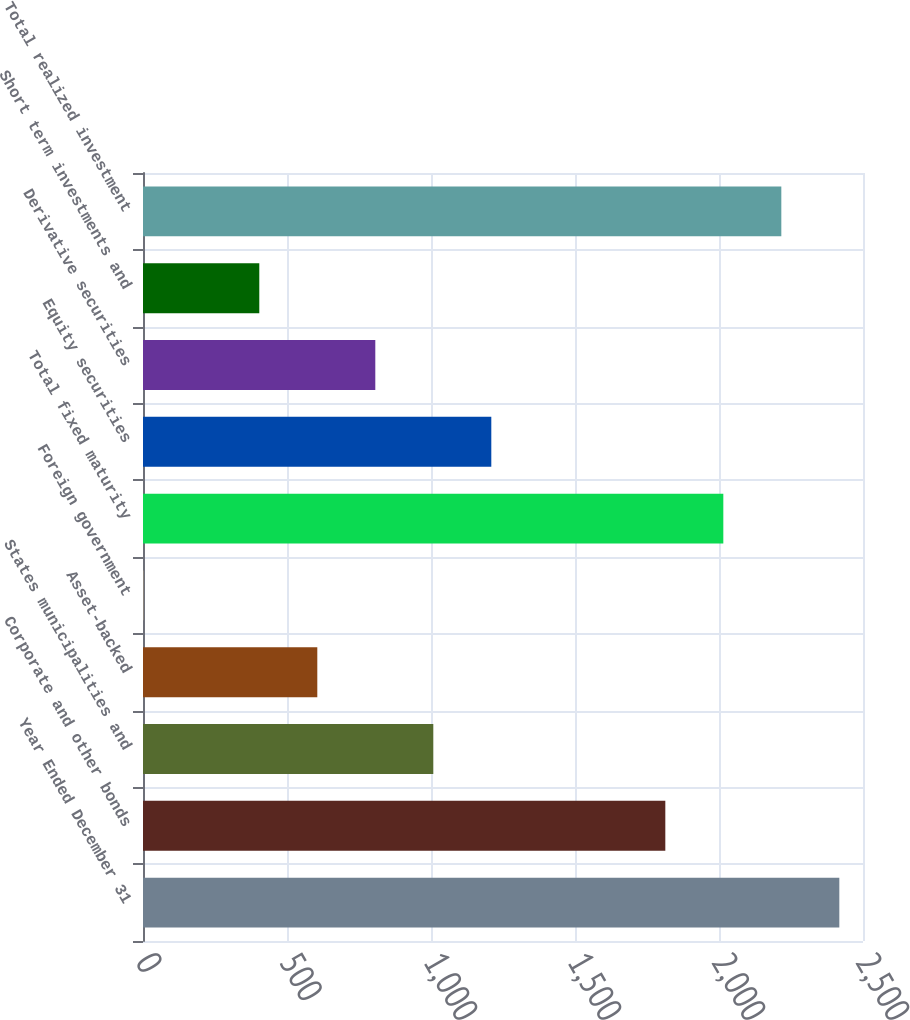Convert chart to OTSL. <chart><loc_0><loc_0><loc_500><loc_500><bar_chart><fcel>Year Ended December 31<fcel>Corporate and other bonds<fcel>States municipalities and<fcel>Asset-backed<fcel>Foreign government<fcel>Total fixed maturity<fcel>Equity securities<fcel>Derivative securities<fcel>Short term investments and<fcel>Total realized investment<nl><fcel>2417.8<fcel>1813.6<fcel>1008<fcel>605.2<fcel>1<fcel>2015<fcel>1209.4<fcel>806.6<fcel>403.8<fcel>2216.4<nl></chart> 